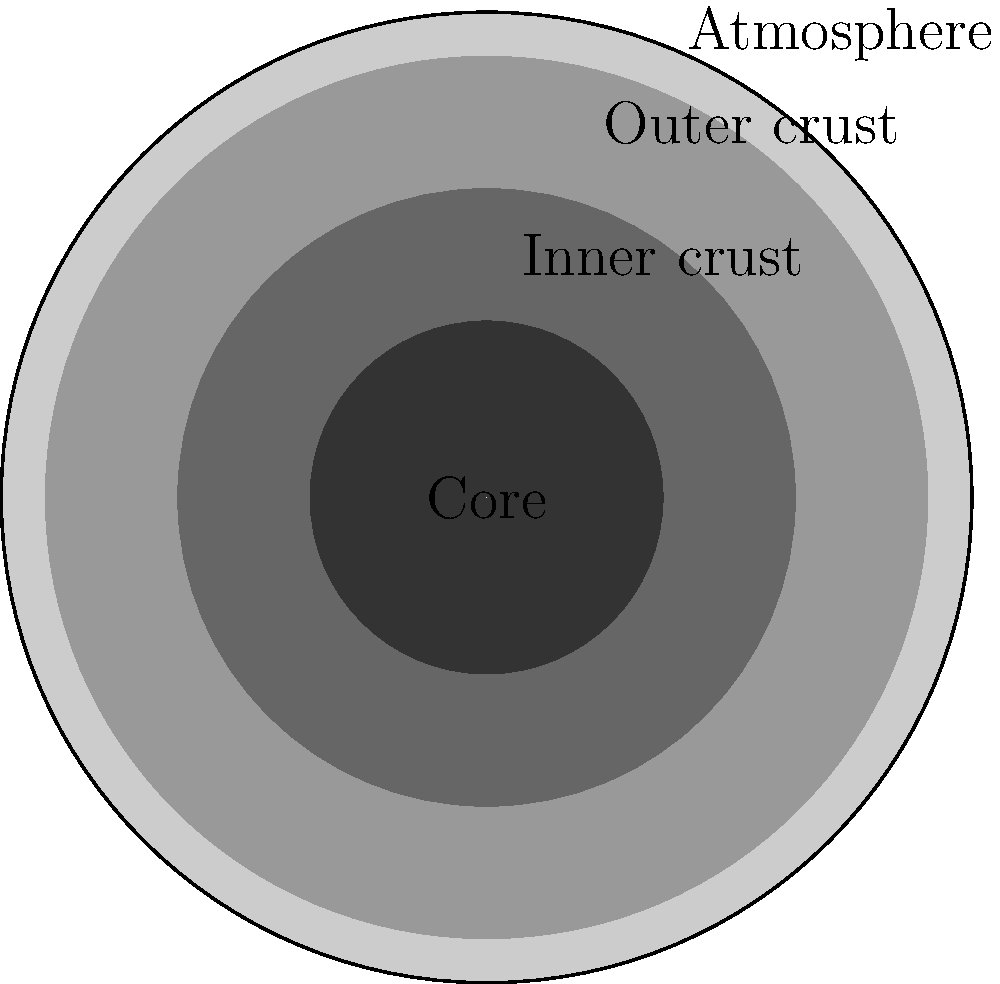As an amateur astronomer exploring bizarre celestial objects, you've come across a neutron star. Which layer of a neutron star contains a lattice of neutron-rich nuclei and free electrons? Let's examine the structure of a neutron star from the outside in:

1. Atmosphere: The outermost layer, extremely thin (about 1 cm thick) and composed of light elements like hydrogen and helium.

2. Outer crust: The next layer inward, about 100 meters thick. It consists of nuclei (mostly iron) arranged in a lattice, surrounded by a sea of electrons.

3. Inner crust: This layer is several kilometers thick. It contains a lattice of neutron-rich nuclei and free electrons, along with free neutrons that have "dripped" out of the nuclei.

4. Core: The innermost and largest part of the neutron star. It's composed mainly of free neutrons, with some protons and electrons.

The question asks about a layer containing a lattice of neutron-rich nuclei and free electrons. This description matches the inner crust of the neutron star.
Answer: Inner crust 